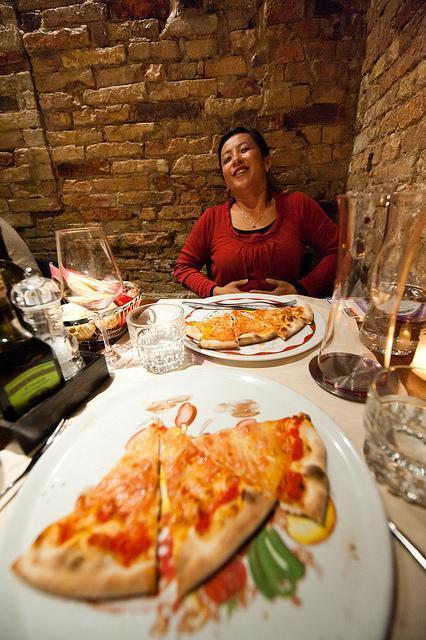How many slices are on the closest plate?
Give a very brief answer. 3. How many cups are visible?
Give a very brief answer. 2. How many bowls can be seen?
Give a very brief answer. 2. How many pizzas can be seen?
Give a very brief answer. 3. How many chairs are in the room?
Give a very brief answer. 0. 